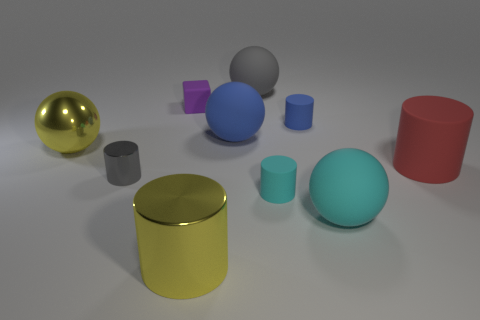Subtract 1 balls. How many balls are left? 3 Subtract all yellow cylinders. How many cylinders are left? 4 Subtract all cyan cylinders. How many cylinders are left? 4 Subtract all green cylinders. Subtract all brown blocks. How many cylinders are left? 5 Subtract all balls. How many objects are left? 6 Add 9 tiny green metal cylinders. How many tiny green metal cylinders exist? 9 Subtract 0 green cylinders. How many objects are left? 10 Subtract all large yellow spheres. Subtract all tiny gray objects. How many objects are left? 8 Add 9 blue balls. How many blue balls are left? 10 